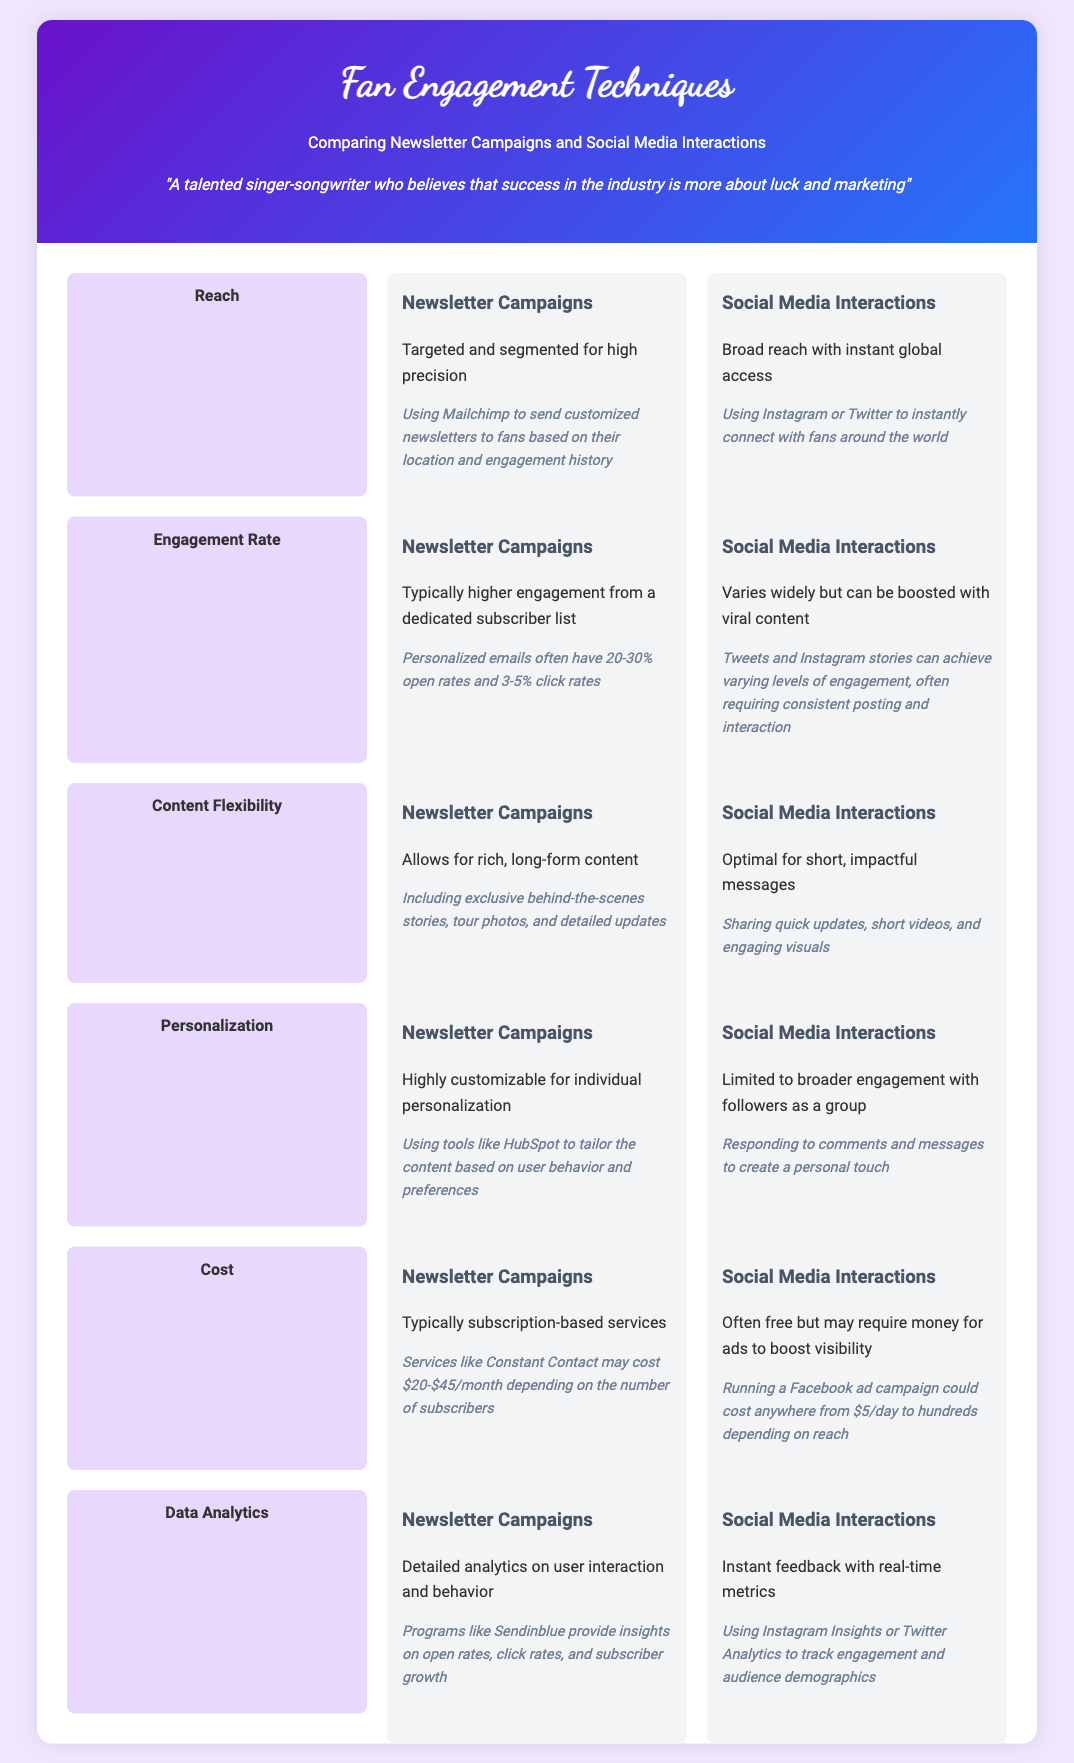What is the engagement rate for newsletter campaigns? The engagement rate for newsletter campaigns is defined as typically higher engagement from a dedicated subscriber list, with specific rates stated as 20-30% open rates and 3-5% click rates.
Answer: 20-30% open rates What is one example of content flexibility for newsletter campaigns? The document mentions that newsletter campaigns allow for rich, long-form content, providing an example of including exclusive behind-the-scenes stories, tour photos, and detailed updates.
Answer: Behind-the-scenes stories What is the cost structure for newsletter campaigns? The cost structure for newsletter campaigns is typically subscription-based services, with a specific example given of services like Constant Contact costing $20-$45/month depending on the number of subscribers.
Answer: $20-$45/month Which technique allows for highly customizable individual personalization? The technique that allows for highly customizable individual personalization is newsletter campaigns, as noted for using tools like HubSpot to tailor content based on user behavior.
Answer: Newsletter campaigns What type of engagement do social media interactions have? Social media interactions are noted to have broader engagement with followers as a group, as per the section on personalization.
Answer: Broader engagement What is a primary analytics feature of newsletter campaigns? The primary analytics feature of newsletter campaigns includes detailed analytics on user interaction and behavior, with an example referring to insights provided by programs like Sendinblue.
Answer: Detailed analytics What is the reach advantage of social media interactions? The reach advantage of social media interactions is described as broad reach with instant global access, emphasizing the ability to connect with fans worldwide.
Answer: Instant global access What is a limitation of social media interactions regarding personalization? The limitation of social media interactions regarding personalization is that they are limited to broader engagement, not allowing for as much individual personalization as newsletter campaigns.
Answer: Limited personalization 